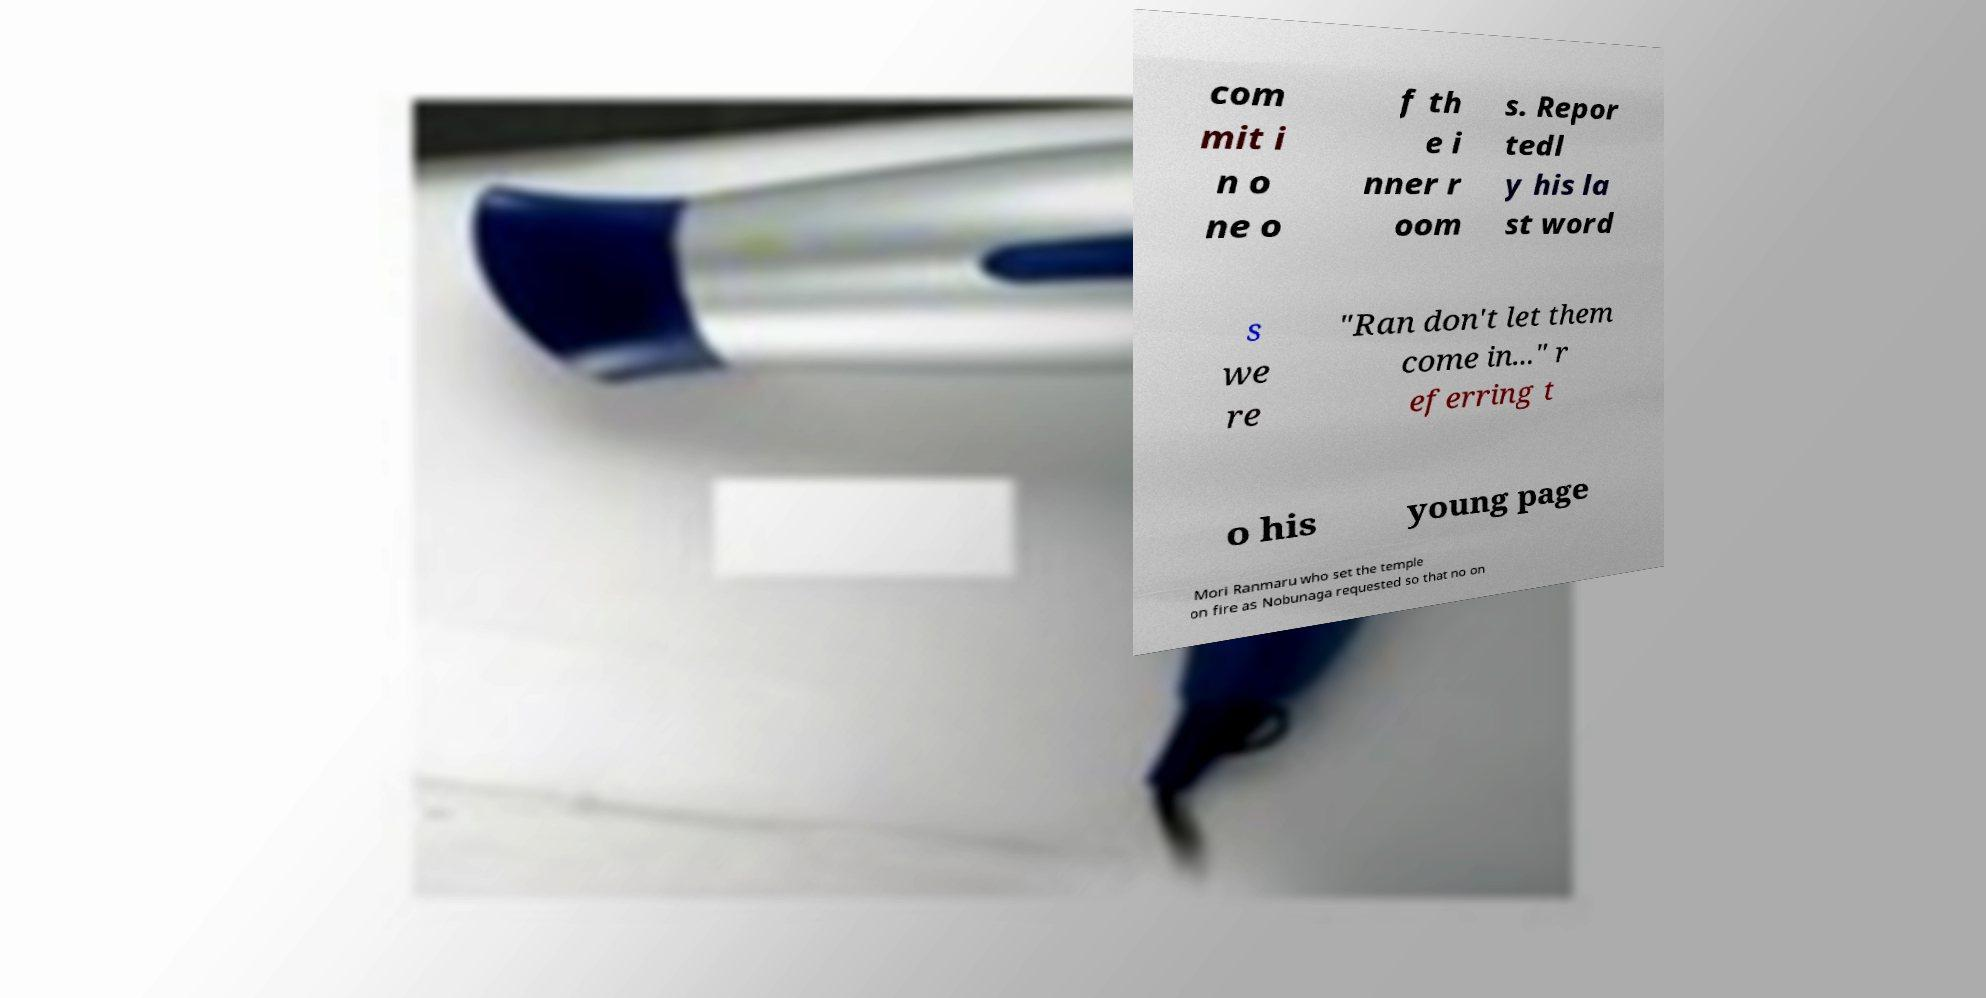Can you accurately transcribe the text from the provided image for me? com mit i n o ne o f th e i nner r oom s. Repor tedl y his la st word s we re "Ran don't let them come in..." r eferring t o his young page Mori Ranmaru who set the temple on fire as Nobunaga requested so that no on 